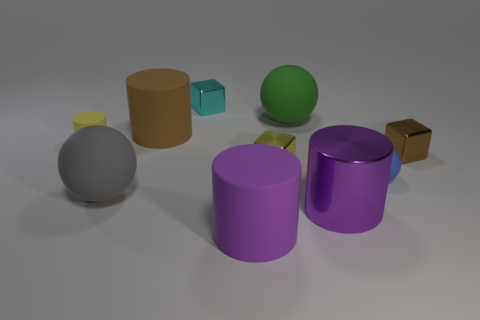What number of matte things are both to the left of the large metallic cylinder and behind the big gray matte thing?
Give a very brief answer. 3. What is the yellow block made of?
Keep it short and to the point. Metal. Is there anything else that is the same color as the large metallic cylinder?
Make the answer very short. Yes. Are the small yellow block and the green thing made of the same material?
Offer a terse response. No. There is a small matte object in front of the yellow thing that is on the right side of the small matte cylinder; how many tiny cubes are behind it?
Provide a succinct answer. 3. What number of small cyan metallic cubes are there?
Your response must be concise. 1. Is the number of small brown objects to the left of the tiny cyan shiny thing less than the number of tiny brown cubes that are behind the green rubber thing?
Your answer should be compact. No. Are there fewer brown matte objects behind the large brown matte cylinder than large brown matte cylinders?
Your response must be concise. Yes. What material is the big sphere that is behind the large matte sphere that is left of the purple thing in front of the metallic cylinder?
Offer a terse response. Rubber. What number of things are either matte objects on the left side of the small rubber ball or things that are to the left of the tiny brown block?
Offer a very short reply. 9. 